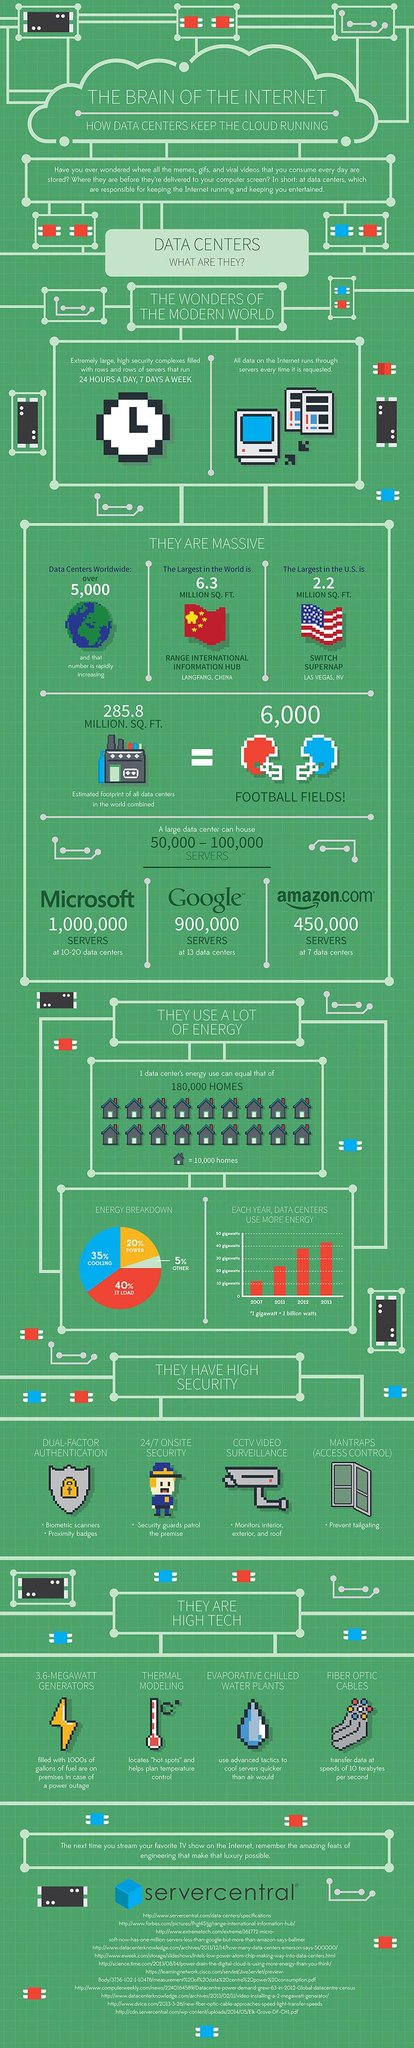Indicate a few pertinent items in this graphic. IT load requires a greater amount of energy consumption compared to other activities. There are 11 sources listed at the bottom. The single house icon represents an estimated 10,000 homes. In 2013, data centers consumed over 40 gigawatts of energy, a significant increase from previous years. Cooling and power consumption consume 55% of the energy breakdown. 